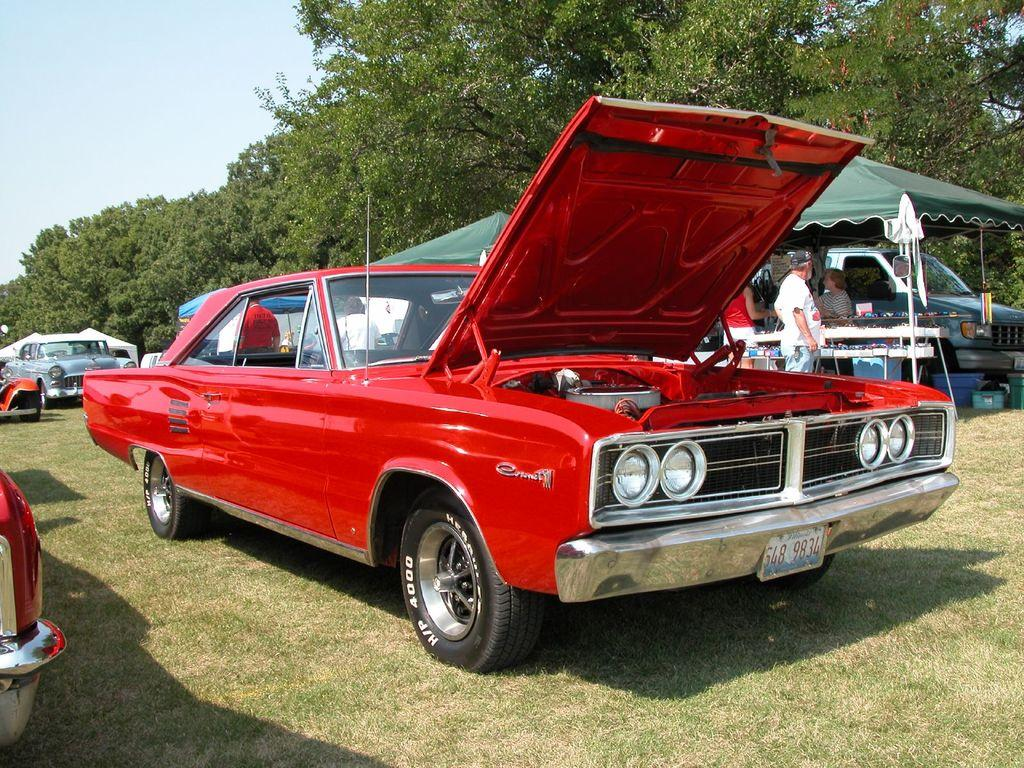What type of vehicles can be seen in the image? There are cars in the image. What can be seen in the distance in the image? There are trees, a tent, and a group of people in the background of the image. What objects are visible in the foreground of the image? There are boxes visible in the image. What type of bean is being used to fuel the cars in the image? There is no bean present in the image, and cars are not fueled by beans. 